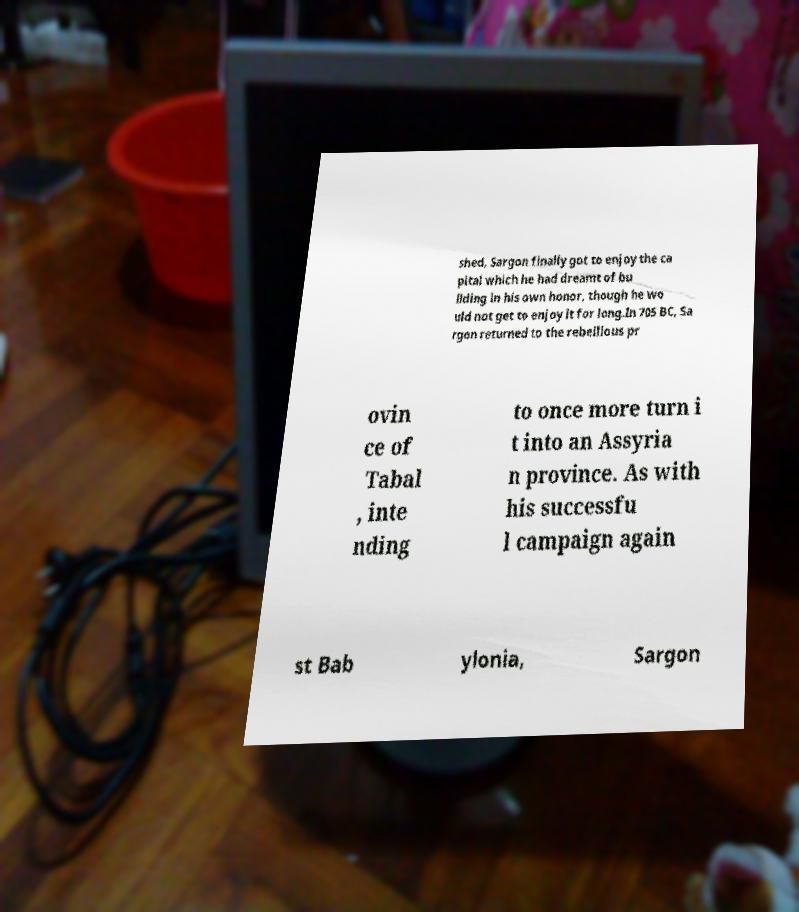Could you assist in decoding the text presented in this image and type it out clearly? shed, Sargon finally got to enjoy the ca pital which he had dreamt of bu ilding in his own honor, though he wo uld not get to enjoy it for long.In 705 BC, Sa rgon returned to the rebellious pr ovin ce of Tabal , inte nding to once more turn i t into an Assyria n province. As with his successfu l campaign again st Bab ylonia, Sargon 